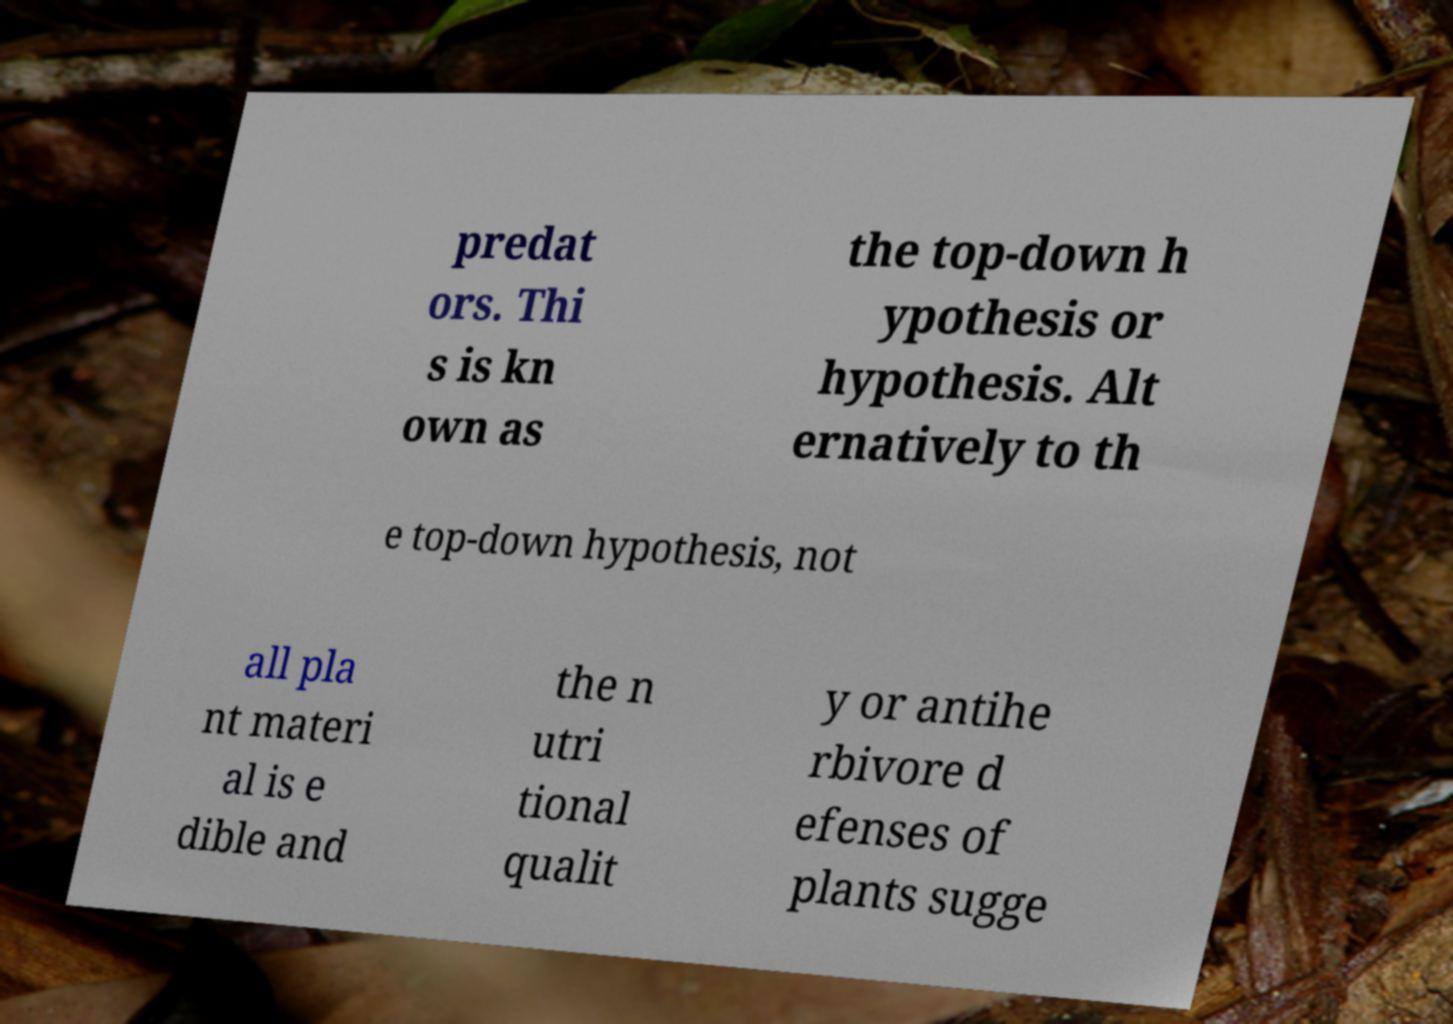There's text embedded in this image that I need extracted. Can you transcribe it verbatim? predat ors. Thi s is kn own as the top-down h ypothesis or hypothesis. Alt ernatively to th e top-down hypothesis, not all pla nt materi al is e dible and the n utri tional qualit y or antihe rbivore d efenses of plants sugge 